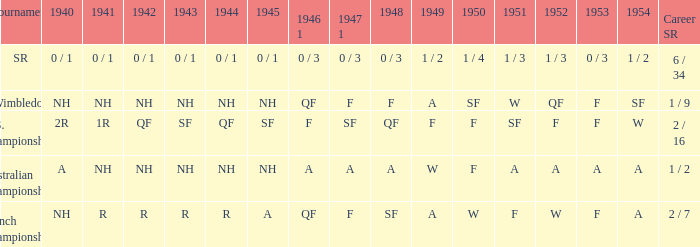What is the 1944 outcome for the u.s. championships? QF. 